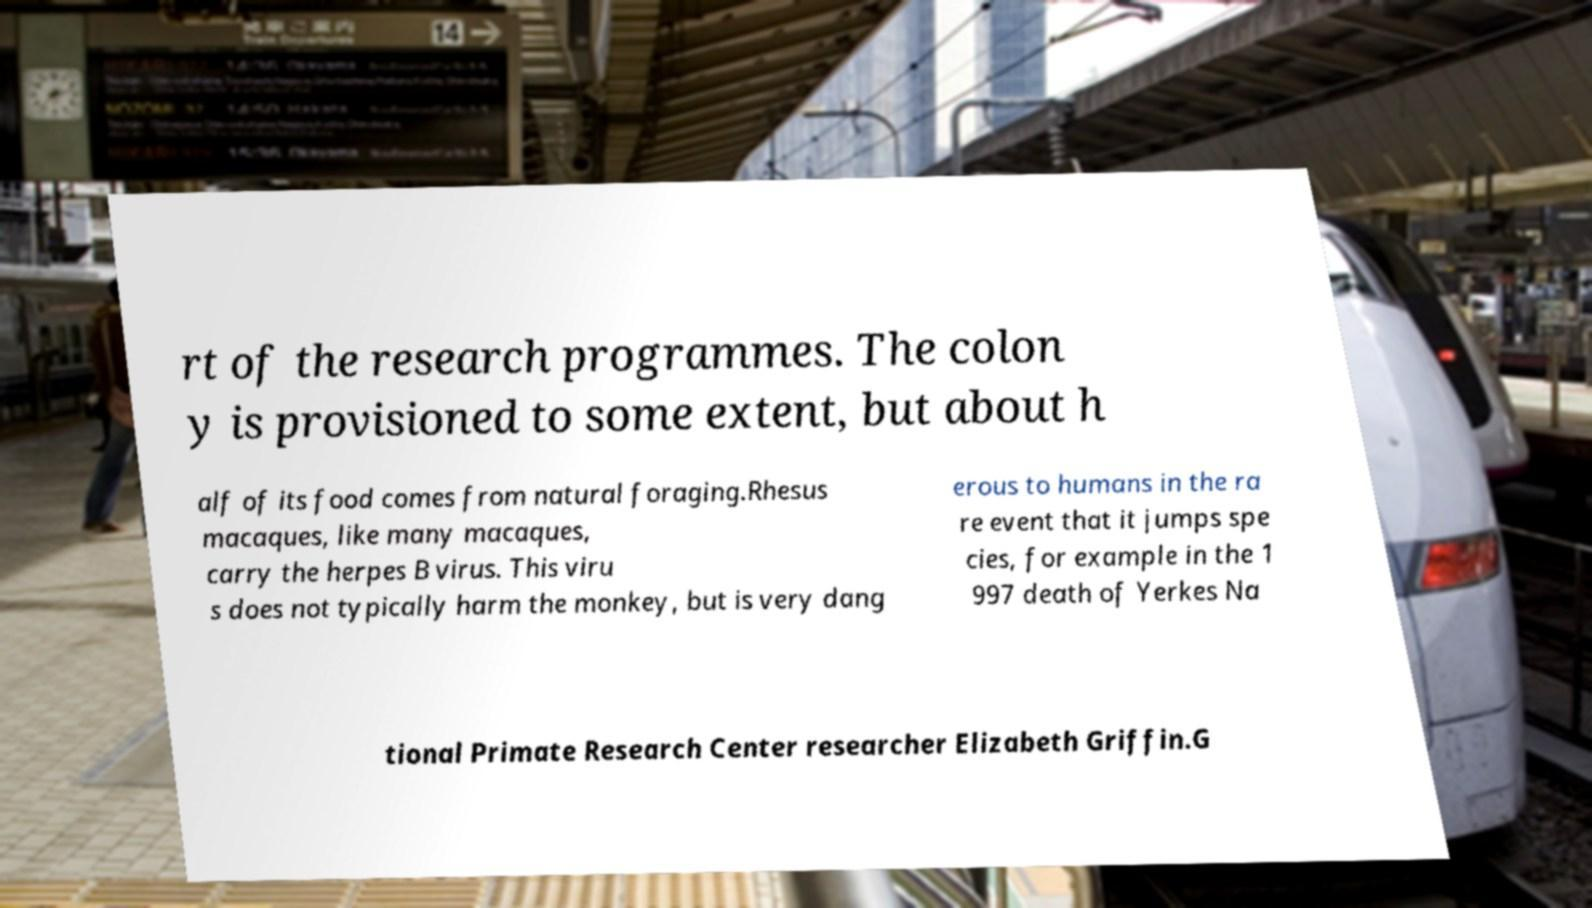For documentation purposes, I need the text within this image transcribed. Could you provide that? rt of the research programmes. The colon y is provisioned to some extent, but about h alf of its food comes from natural foraging.Rhesus macaques, like many macaques, carry the herpes B virus. This viru s does not typically harm the monkey, but is very dang erous to humans in the ra re event that it jumps spe cies, for example in the 1 997 death of Yerkes Na tional Primate Research Center researcher Elizabeth Griffin.G 